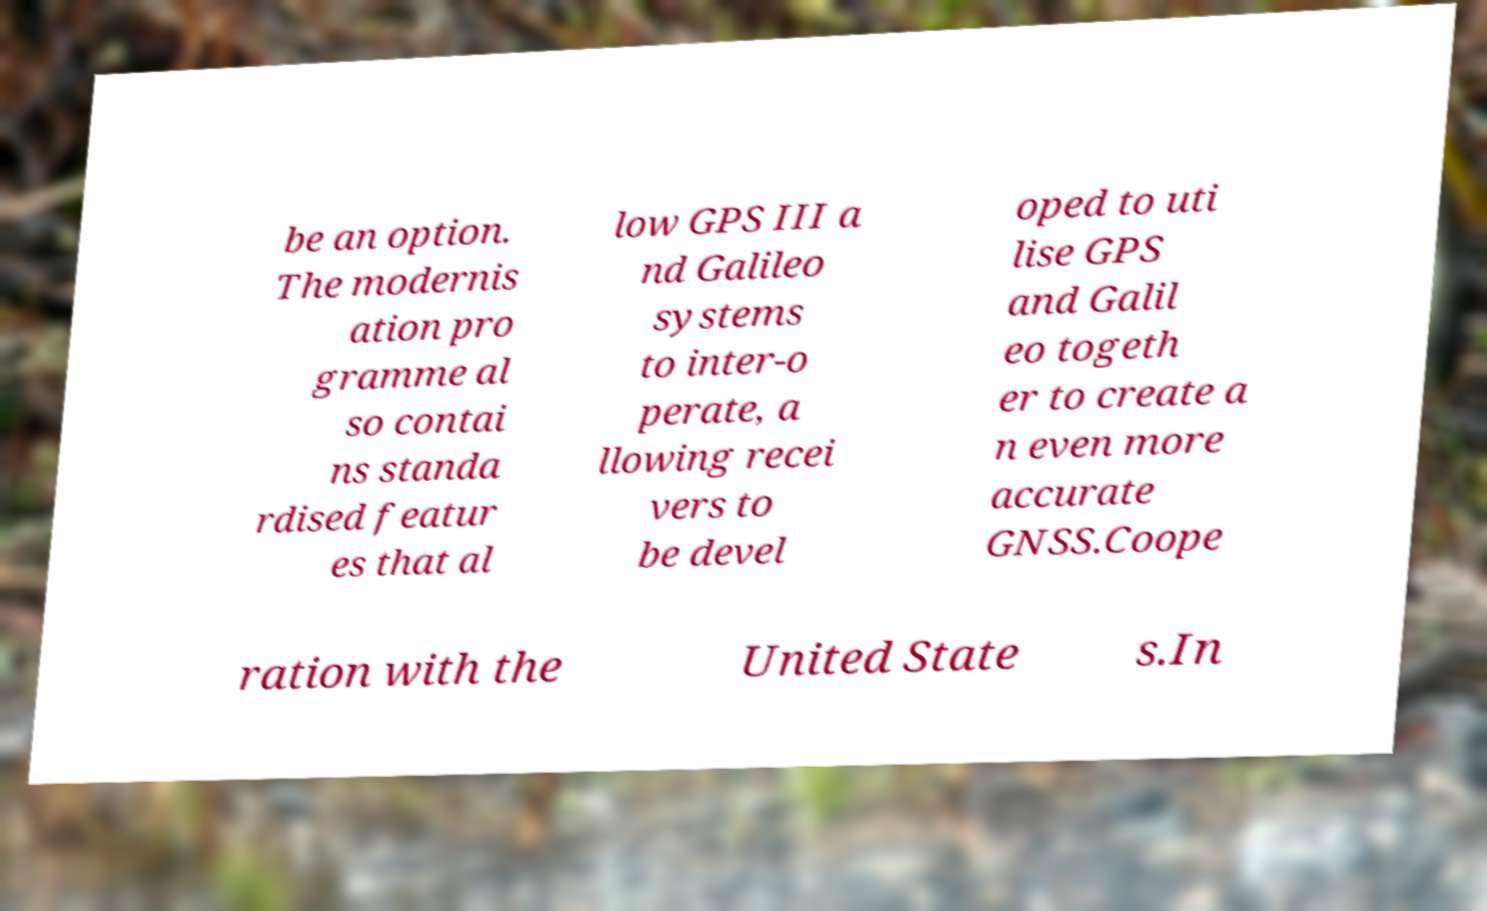Please identify and transcribe the text found in this image. be an option. The modernis ation pro gramme al so contai ns standa rdised featur es that al low GPS III a nd Galileo systems to inter-o perate, a llowing recei vers to be devel oped to uti lise GPS and Galil eo togeth er to create a n even more accurate GNSS.Coope ration with the United State s.In 